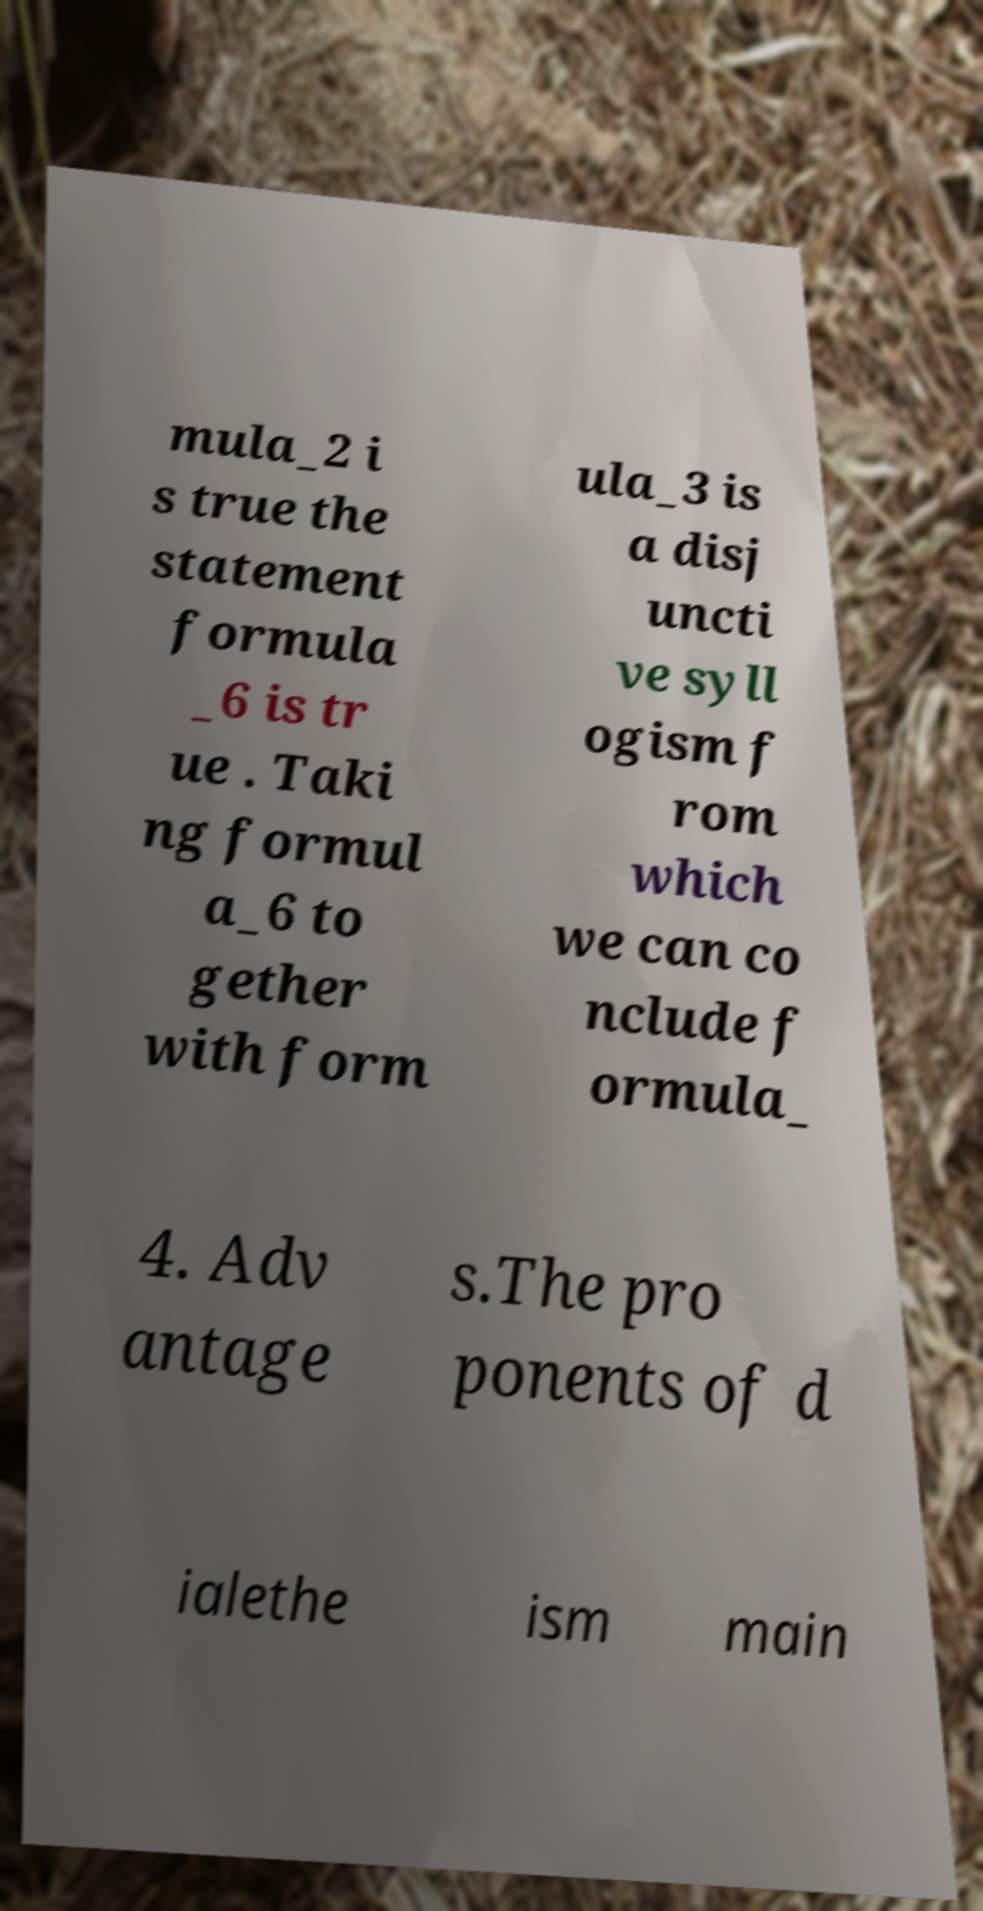Could you assist in decoding the text presented in this image and type it out clearly? mula_2 i s true the statement formula _6 is tr ue . Taki ng formul a_6 to gether with form ula_3 is a disj uncti ve syll ogism f rom which we can co nclude f ormula_ 4. Adv antage s.The pro ponents of d ialethe ism main 